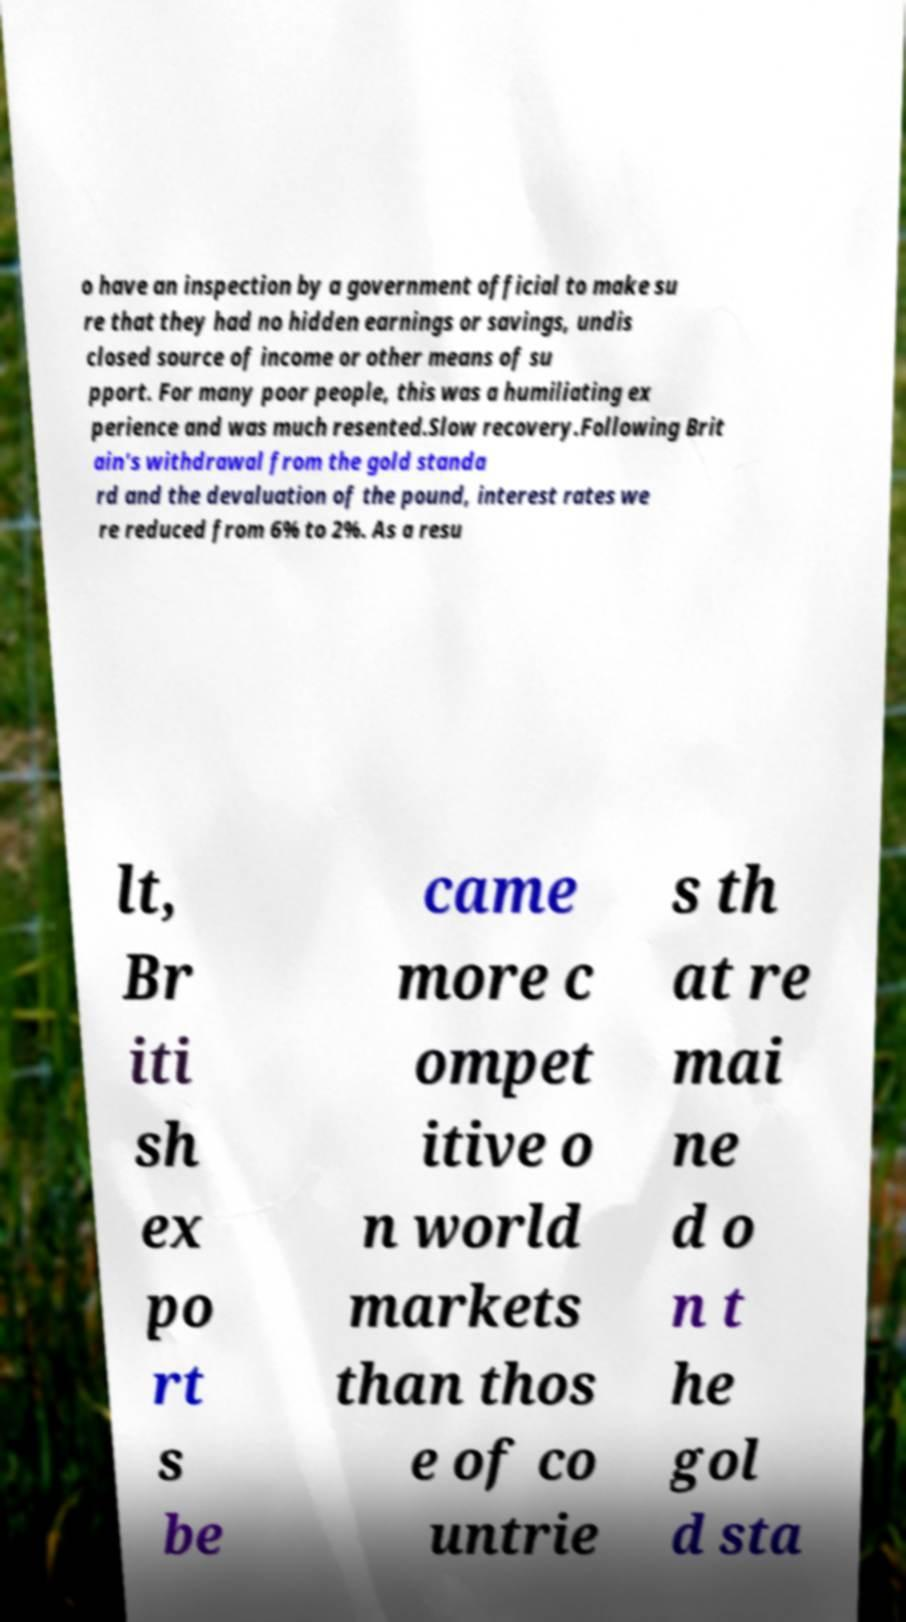Can you read and provide the text displayed in the image?This photo seems to have some interesting text. Can you extract and type it out for me? o have an inspection by a government official to make su re that they had no hidden earnings or savings, undis closed source of income or other means of su pport. For many poor people, this was a humiliating ex perience and was much resented.Slow recovery.Following Brit ain's withdrawal from the gold standa rd and the devaluation of the pound, interest rates we re reduced from 6% to 2%. As a resu lt, Br iti sh ex po rt s be came more c ompet itive o n world markets than thos e of co untrie s th at re mai ne d o n t he gol d sta 